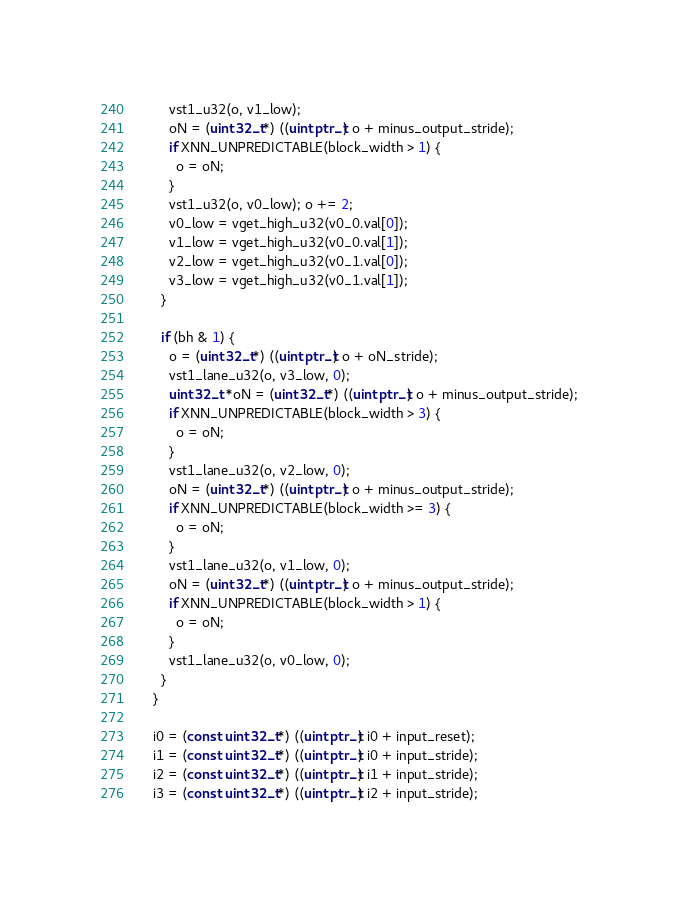<code> <loc_0><loc_0><loc_500><loc_500><_C_>        vst1_u32(o, v1_low);
        oN = (uint32_t*) ((uintptr_t) o + minus_output_stride);
        if XNN_UNPREDICTABLE(block_width > 1) {
          o = oN;
        }
        vst1_u32(o, v0_low); o += 2;
        v0_low = vget_high_u32(v0_0.val[0]);
        v1_low = vget_high_u32(v0_0.val[1]);
        v2_low = vget_high_u32(v0_1.val[0]);
        v3_low = vget_high_u32(v0_1.val[1]);
      }

      if (bh & 1) {
        o = (uint32_t*) ((uintptr_t) o + oN_stride);
        vst1_lane_u32(o, v3_low, 0);
        uint32_t *oN = (uint32_t*) ((uintptr_t) o + minus_output_stride);
        if XNN_UNPREDICTABLE(block_width > 3) {
          o = oN;
        }
        vst1_lane_u32(o, v2_low, 0);
        oN = (uint32_t*) ((uintptr_t) o + minus_output_stride);
        if XNN_UNPREDICTABLE(block_width >= 3) {
          o = oN;
        }
        vst1_lane_u32(o, v1_low, 0);
        oN = (uint32_t*) ((uintptr_t) o + minus_output_stride);
        if XNN_UNPREDICTABLE(block_width > 1) {
          o = oN;
        }
        vst1_lane_u32(o, v0_low, 0);
      }
    }

    i0 = (const uint32_t*) ((uintptr_t) i0 + input_reset);
    i1 = (const uint32_t*) ((uintptr_t) i0 + input_stride);
    i2 = (const uint32_t*) ((uintptr_t) i1 + input_stride);
    i3 = (const uint32_t*) ((uintptr_t) i2 + input_stride);</code> 